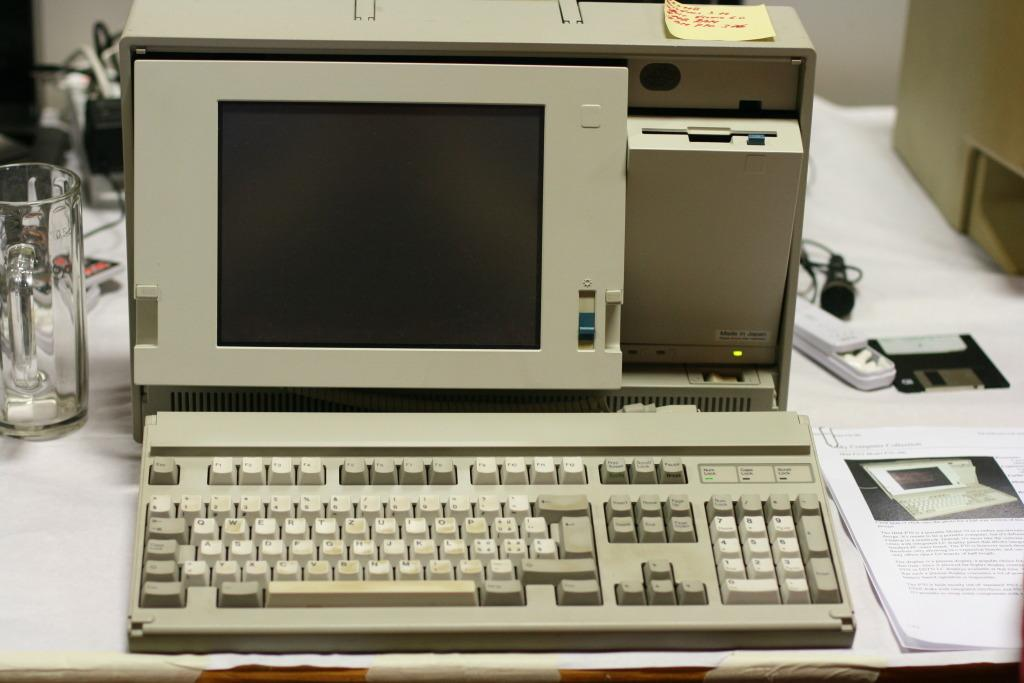What is the main structure visible in the image? There is a platform in the image. What electronic devices are on the platform? A monitor, keyboard, CPU, and microphone are on the platform. What non-electronic items are on the platform? There is a glass, a battery, papers, and some unspecified objects on the platform. What can be seen in the background of the image? There is a wall in the background of the image. Can you tell me how many brushes are on the platform in the image? There is no brush present on the platform in the image. Is there a step ladder visible in the image? There is no step ladder visible in the image. 